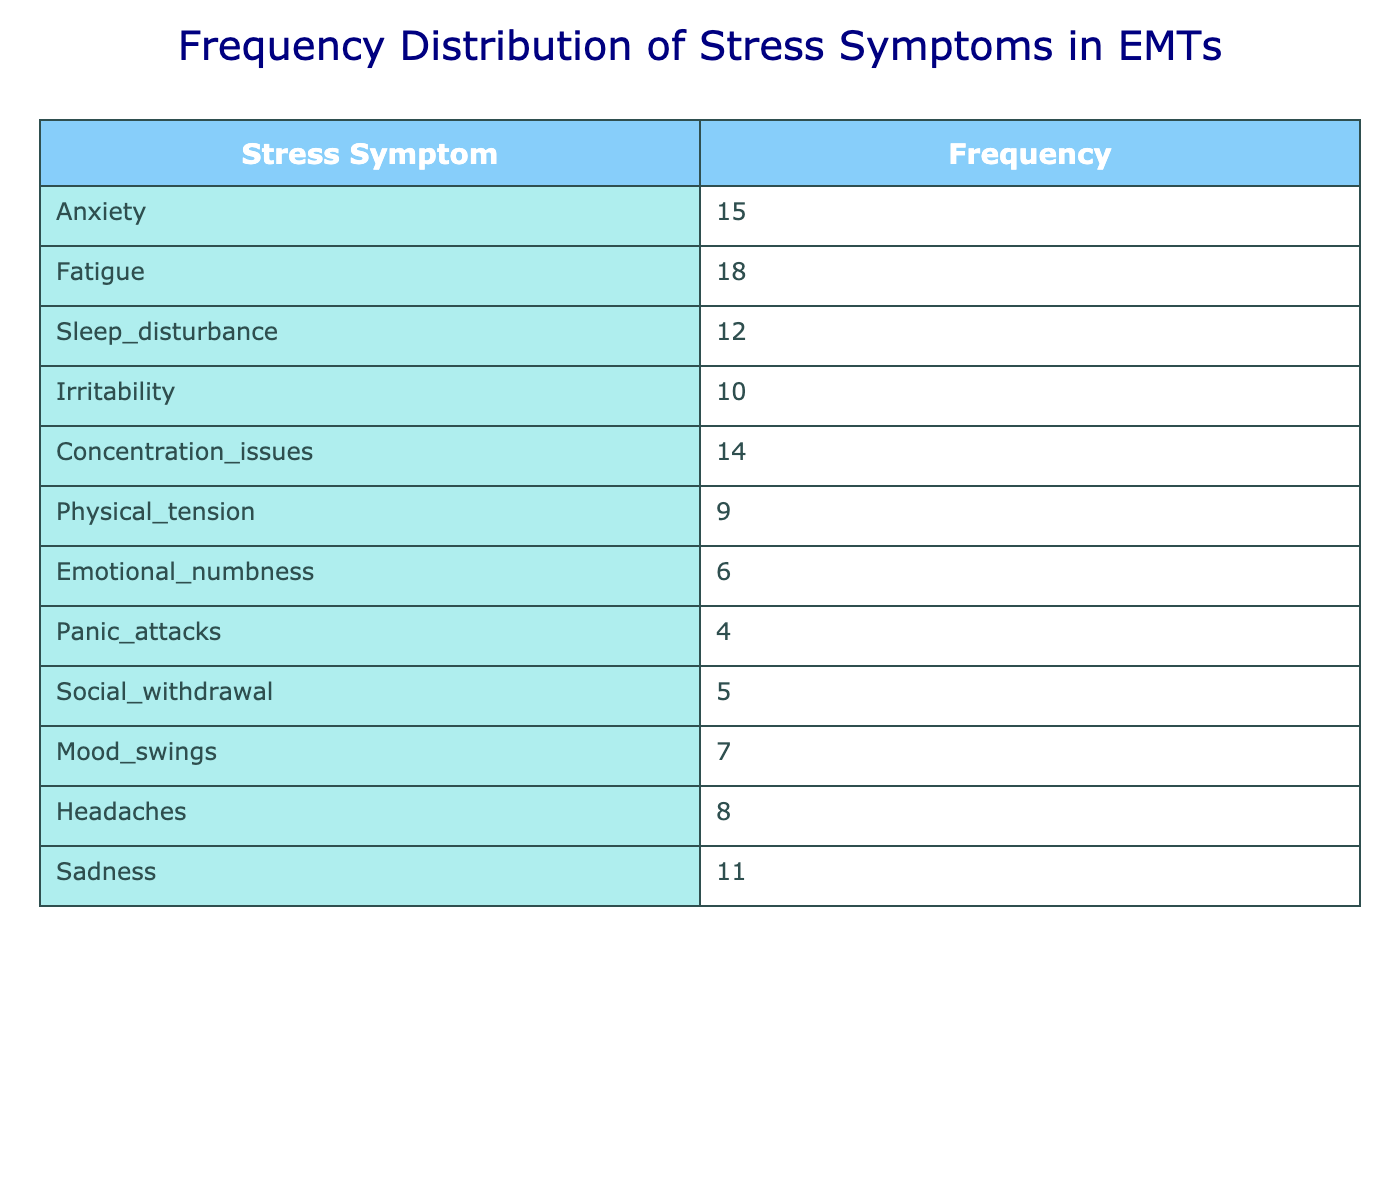What is the frequency of anxiety symptoms reported by EMTs? According to the table, anxiety is listed under the Stress Symptom category with a frequency of 15.
Answer: 15 Which symptom has the highest reported frequency? By examining the frequencies listed in the table, fatigue has the highest frequency at 18, more than any other symptom.
Answer: Fatigue What is the total frequency of emotional numbness and panic attacks combined? The frequency of emotional numbness is 6, and the frequency of panic attacks is 4. Adding these together gives 6 + 4 = 10.
Answer: 10 How many symptoms have a frequency of 10 or greater? The symptoms with frequencies of 10 or greater are anxiety (15), fatigue (18), concentration issues (14), sadness (11), and irritability (10). This totals to 5 symptoms.
Answer: 5 Is the frequency of headaches higher than the frequency of mood swings? The table shows that headaches have a frequency of 8 and mood swings have a frequency of 7. Since 8 is greater than 7, the statement is true.
Answer: Yes What is the average frequency of all reported stress symptoms? To calculate the average, we sum all frequencies: 15 + 18 + 12 + 10 + 14 + 9 + 6 + 4 + 5 + 7 + 8 + 11 =  119. There are 12 symptoms, so we divide the total by 12: 119 / 12 = 9.92.
Answer: 9.92 What is the difference in frequency between the most and least reported stress symptoms? The most reported symptom is fatigue with a frequency of 18, and the least is panic attacks with 4. The difference is 18 - 4 = 14.
Answer: 14 Are there any symptoms reported with a frequency lower than 5? Upon checking the table, the lowest frequency reported is 4 for panic attacks, meaning there is indeed at least one symptom below 5.
Answer: Yes What is the cumulative frequency of the symptoms reported as irritability, physical tension, and social withdrawal? For irritability the frequency is 10, physical tension is 9, and social withdrawal is 5. Adding these together gives 10 + 9 + 5 = 24.
Answer: 24 